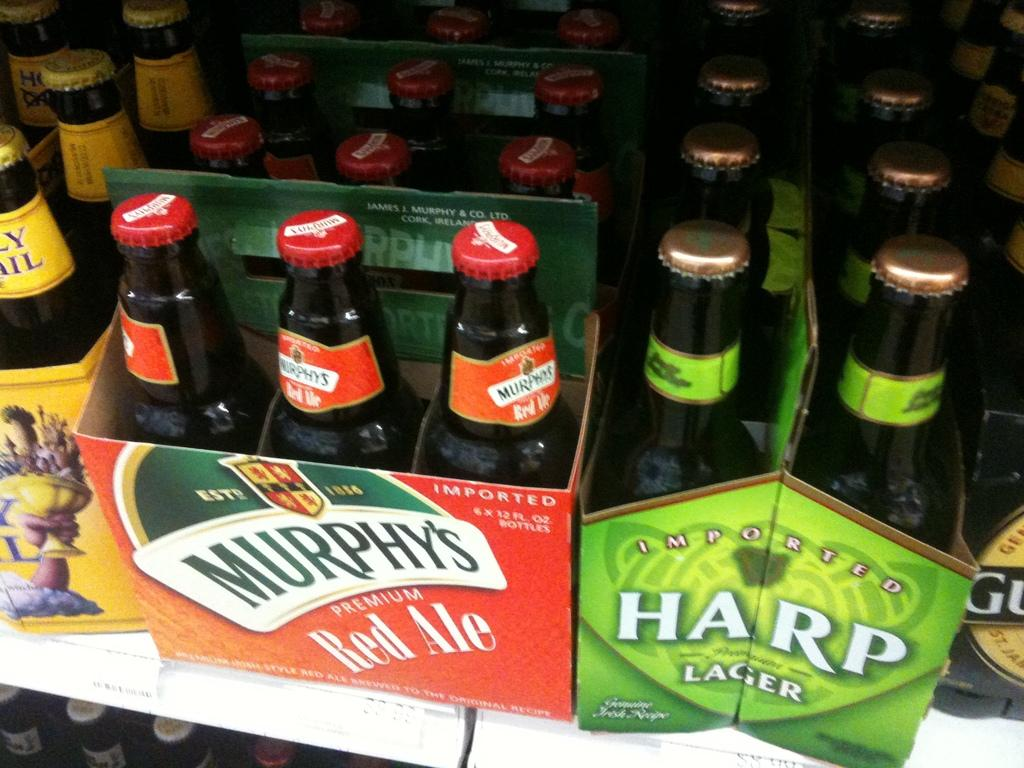<image>
Give a short and clear explanation of the subsequent image. A six pack of Harp lager sits next to Murphy's six pack. 